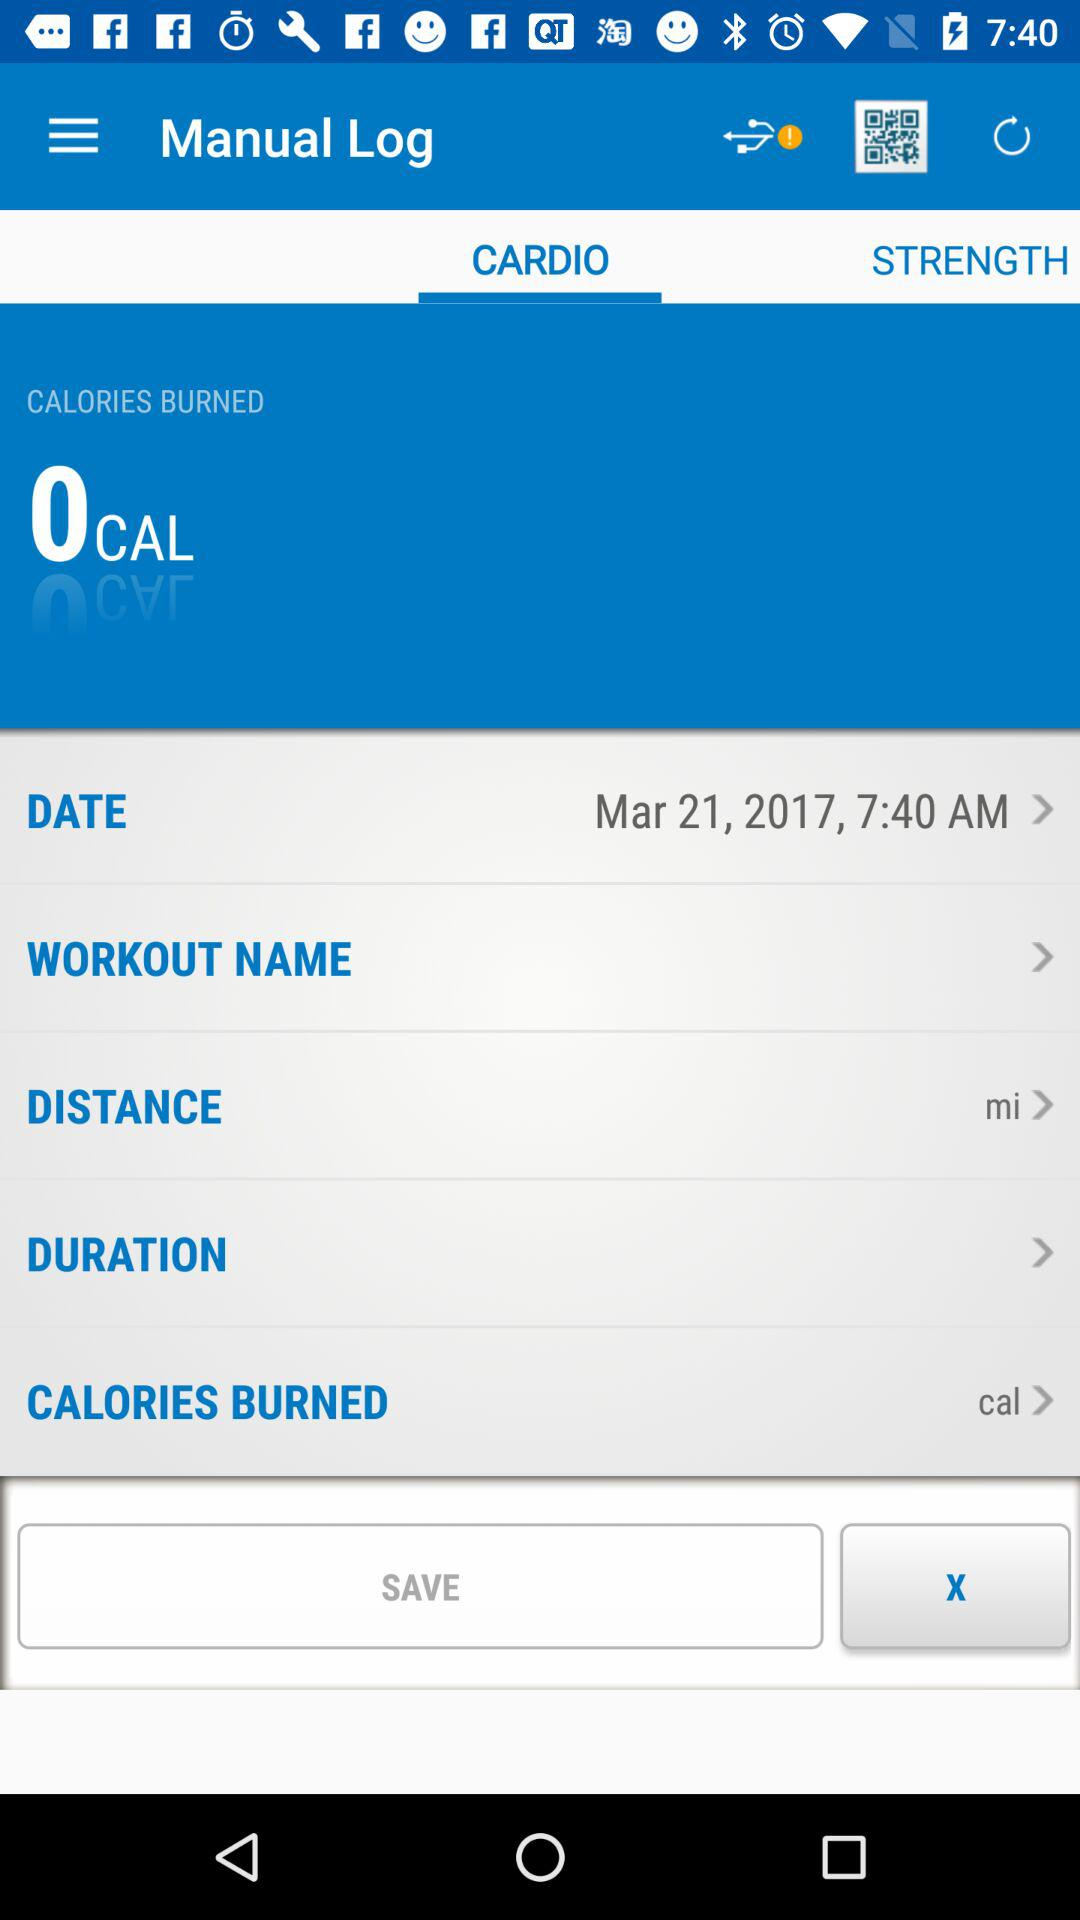What is the date? The date is March 21, 2017. 